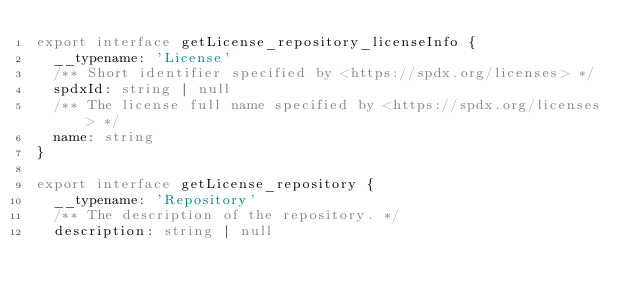<code> <loc_0><loc_0><loc_500><loc_500><_TypeScript_>export interface getLicense_repository_licenseInfo {
  __typename: 'License'
  /** Short identifier specified by <https://spdx.org/licenses> */
  spdxId: string | null
  /** The license full name specified by <https://spdx.org/licenses> */
  name: string
}

export interface getLicense_repository {
  __typename: 'Repository'
  /** The description of the repository. */
  description: string | null</code> 